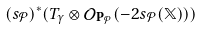Convert formula to latex. <formula><loc_0><loc_0><loc_500><loc_500>( s _ { \mathcal { P } } ) ^ { * } ( T _ { \gamma } \otimes { \mathcal { O } } _ { { \mathbf P } _ { \mathcal { P } } } ( - 2 s _ { \mathcal { P } } ( { \mathbb { X } } ) ) )</formula> 